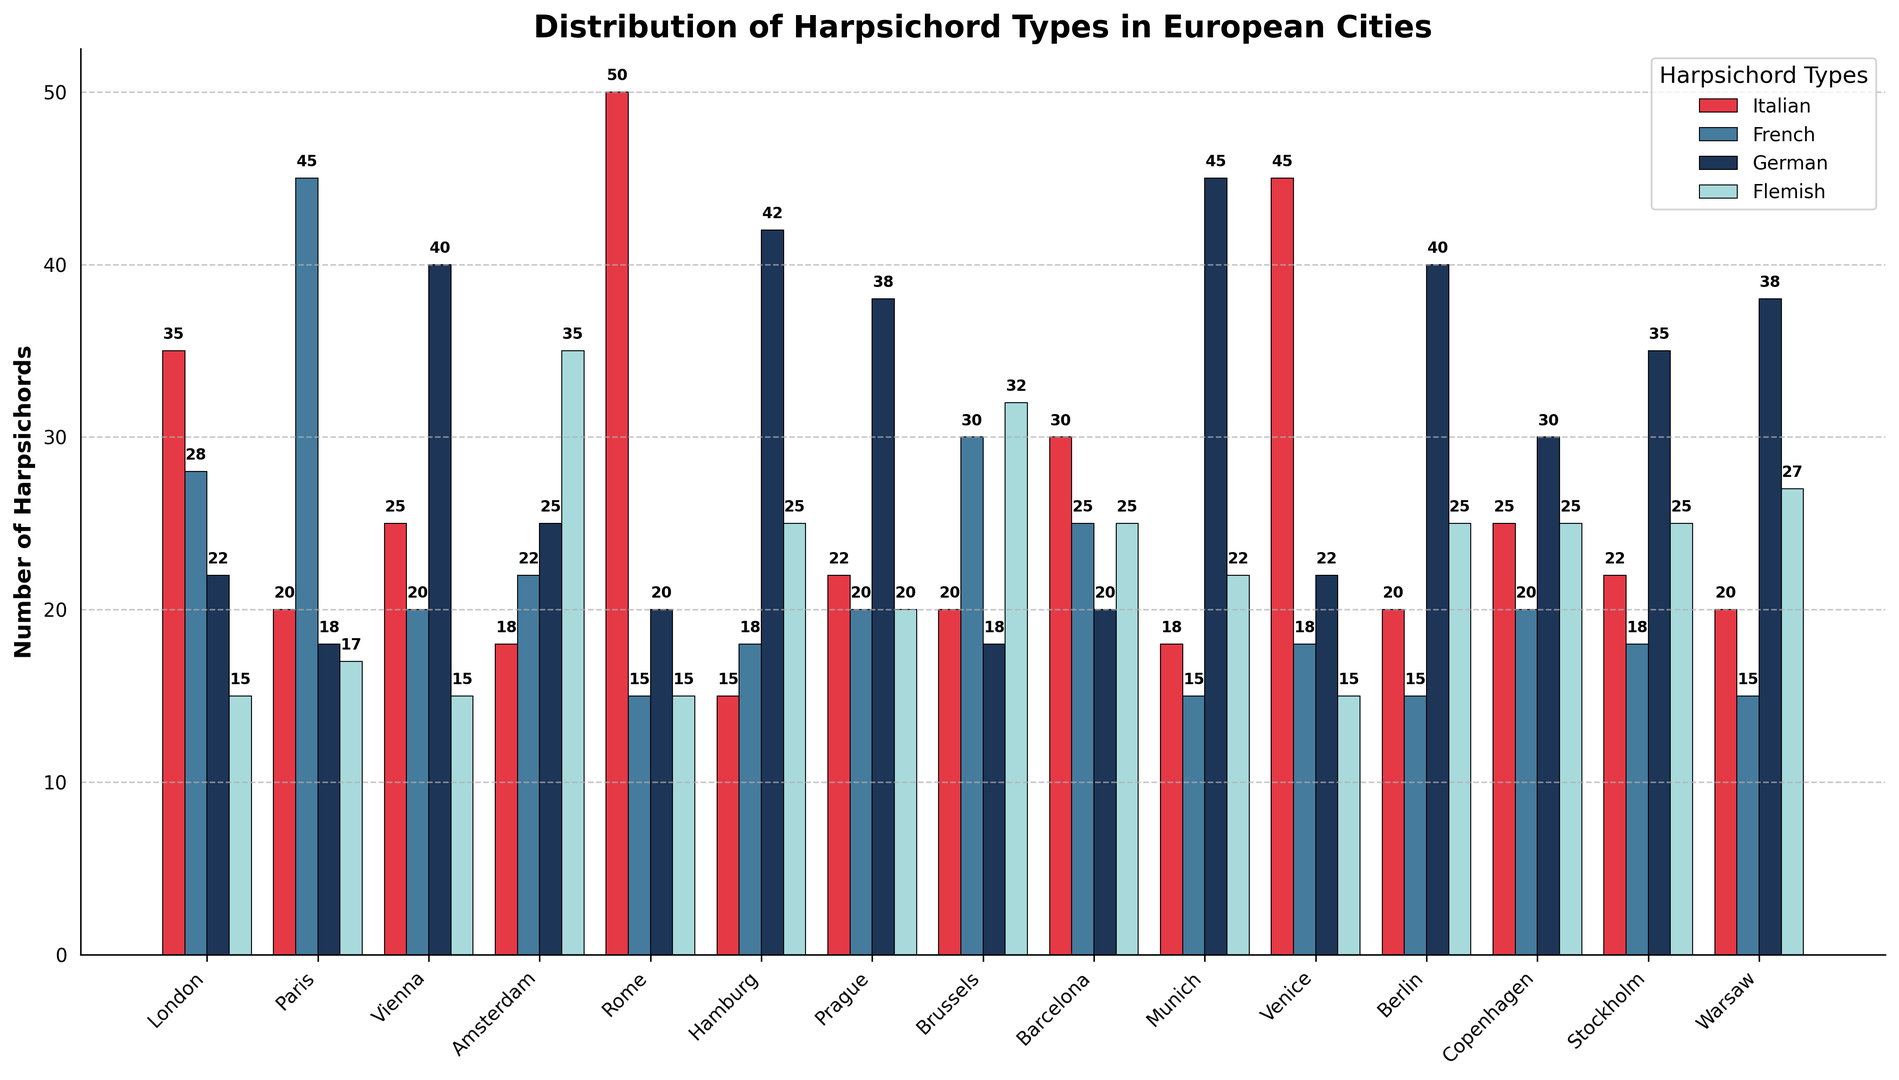Which city has the highest number of Italian harpsichords? The city with the highest bar in the Italian category (red bars) is Rome with 50 harpsichords.
Answer: Rome Which cities have more than 40 German harpsichords? The cities where the height of the bars in the German category (blue bars) exceeds 40 are Vienna, Munich, and Berlin.
Answer: Vienna, Munich, Berlin Which city has the lowest number of French harpsichords? The shortest bar in the French category (blue bars) is in Rome, showing 15 French harpsichords.
Answer: Rome How many Flemish harpsichords are there in Amsterdam and Brussels combined? The heights of the Flemish category (green bars) in Amsterdam and Brussels are 35 and 32, respectively. Summing them gives 35 + 32 = 67.
Answer: 67 Compare the total number of harpsichords (all types) in Paris and Barcelona. Which city has more? Summing the bars for each type in Paris: 20 (Italian) + 45 (French) + 18 (German) + 17 (Flemish) = 100. For Barcelona: 30 (Italian) + 25 (French) + 20 (German) + 25 (Flemish) = 100. Both cities have an equal total number of harpsichords.
Answer: Equal On average, how many harpsichords of each type are there in Stockholm? Sum all harpsichords in Stockholm: 22 (Italian) + 18 (French) + 35 (German) + 25 (Flemish) = 100. The average for 4 types is 100/4 = 25.
Answer: 25 Which city has the second highest number of Flemish harpsichords? The second highest bar in the Flemish category (green bars) is in Amsterdam with 35 Flemish harpsichords, after Warsaw with the highest.
Answer: Amsterdam In which city are German harpsichords the predominant type? Hamburg has 42 German harpsichords, significantly more than the other types of harpsichords.
Answer: Hamburg What's the average number of Italian harpsichords in the cities listed? Sum the Italian harpsichords across all cities: 35 + 20 + 25 + 18 + 50 + 15 + 22 + 20 + 30 + 18 + 45 + 20 + 25 + 22 + 20 = 385. There are 15 cities, so the average is 385/15 = ~25.67.
Answer: ~25.67 Are there more French harpsichords in Paris or in Brussels? The height of the bar in the French category (blue bar) for Paris is 45, while for Brussels, it is 30. 45 > 30, so Paris has more French harpsichords.
Answer: Paris 